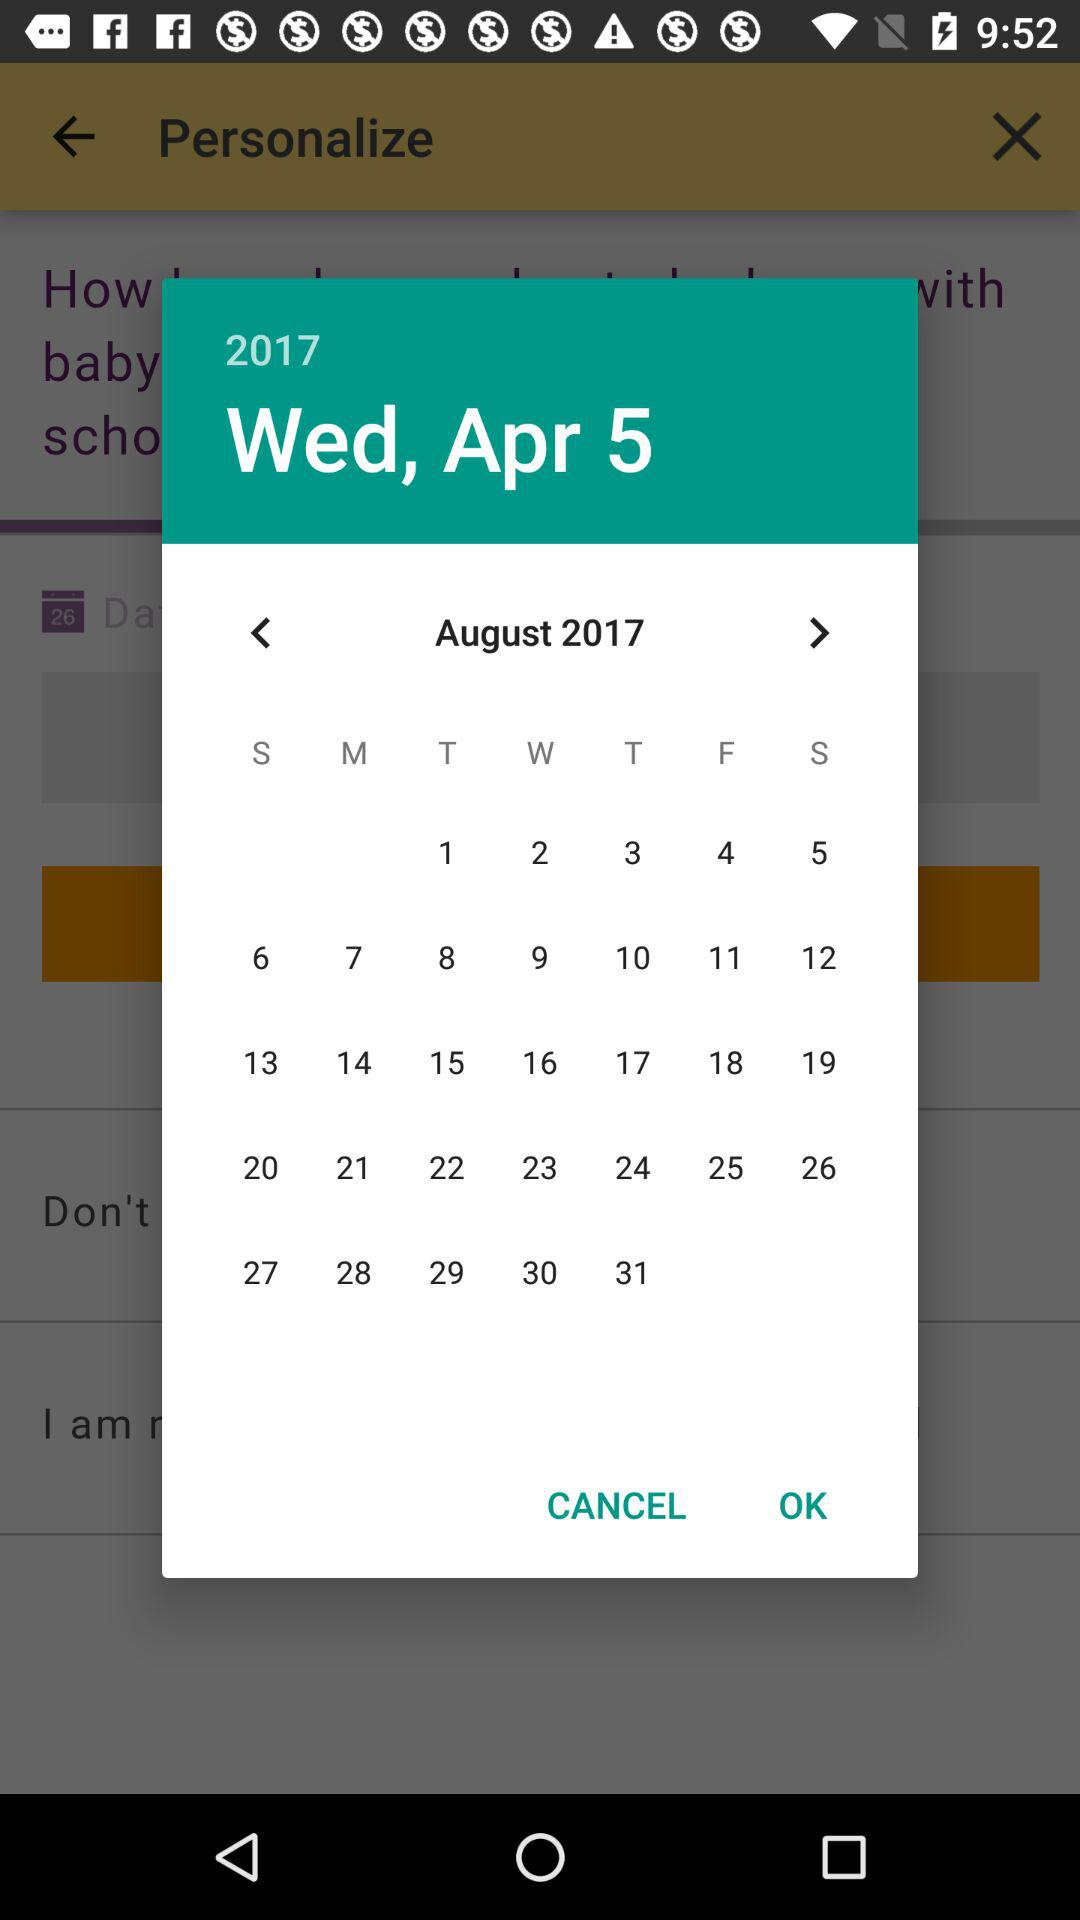What is the selected date? The selected date is Wednesday, April 5, 2017. 